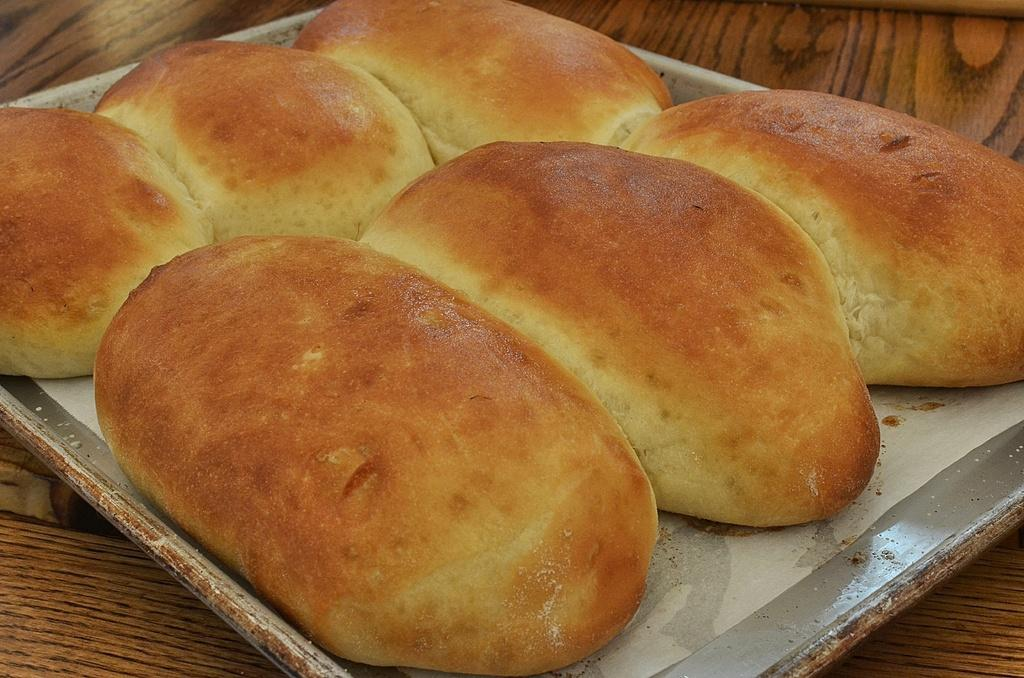What piece of furniture is present in the image? There is a table in the image. What is placed on the table? There is a tray on the table. What type of food can be seen on the tray? There are buns on the tray. Where is the shelf located in the image? There is no shelf present in the image. What is the afterthought in the image? The image does not depict an afterthought, as it is a still image and not a thought process. 